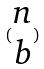Convert formula to latex. <formula><loc_0><loc_0><loc_500><loc_500>( \begin{matrix} n \\ b \end{matrix} )</formula> 